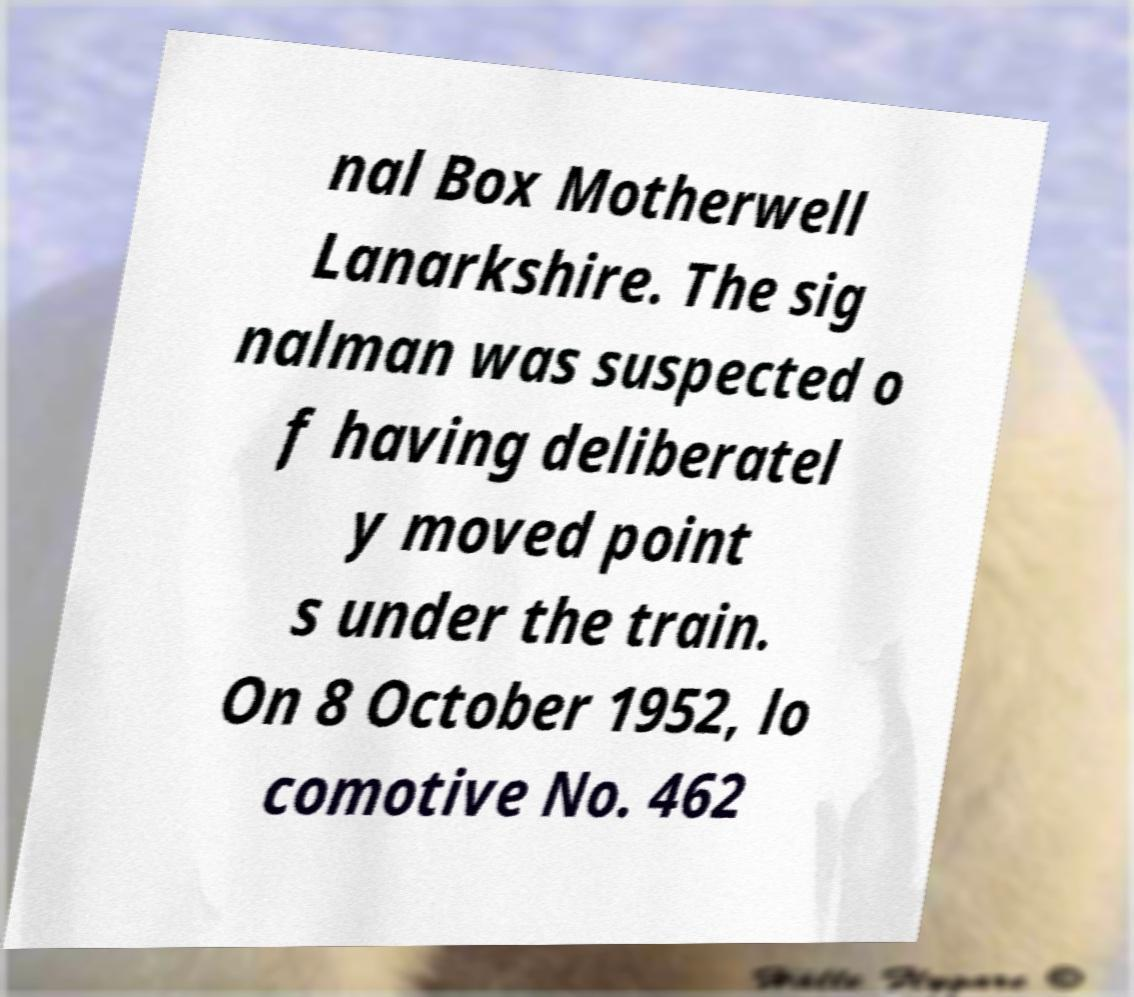Could you assist in decoding the text presented in this image and type it out clearly? nal Box Motherwell Lanarkshire. The sig nalman was suspected o f having deliberatel y moved point s under the train. On 8 October 1952, lo comotive No. 462 